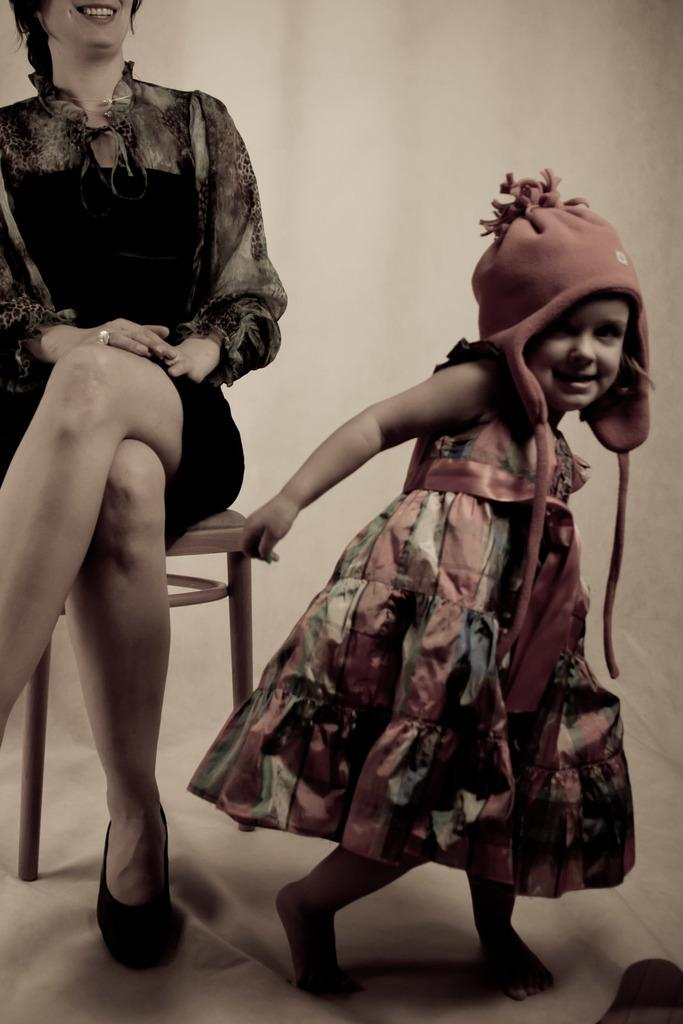What is the woman doing in the image? The woman is sitting on a chair in the image. What is the kid doing in the image? The kid is standing on the ground in the image. What can be seen in the background of the image? There is a wall visible in the background of the image. What type of pickle is the woman holding in the image? There is no pickle present in the image; the woman is sitting on a chair. How many hands does the kid have in the image? The image does not show the number of hands the kid has, but it is common for humans to have two hands. 